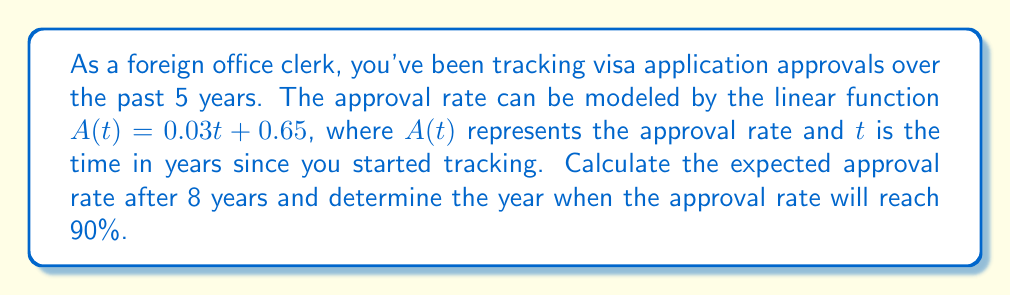What is the answer to this math problem? 1. To find the approval rate after 8 years:
   Substitute $t = 8$ into the given function:
   $A(8) = 0.03(8) + 0.65$
   $A(8) = 0.24 + 0.65 = 0.89$
   The approval rate after 8 years will be 0.89 or 89%.

2. To determine when the approval rate will reach 90%:
   Set $A(t) = 0.90$ and solve for $t$:
   $0.90 = 0.03t + 0.65$
   $0.25 = 0.03t$
   $t = 0.25 / 0.03 = 8.33$

   Since $t$ represents years since tracking began, we need to round up to the next whole year.
   Therefore, the approval rate will reach 90% in the 9th year of tracking.
Answer: 89% after 8 years; 90% reached in 9th year 